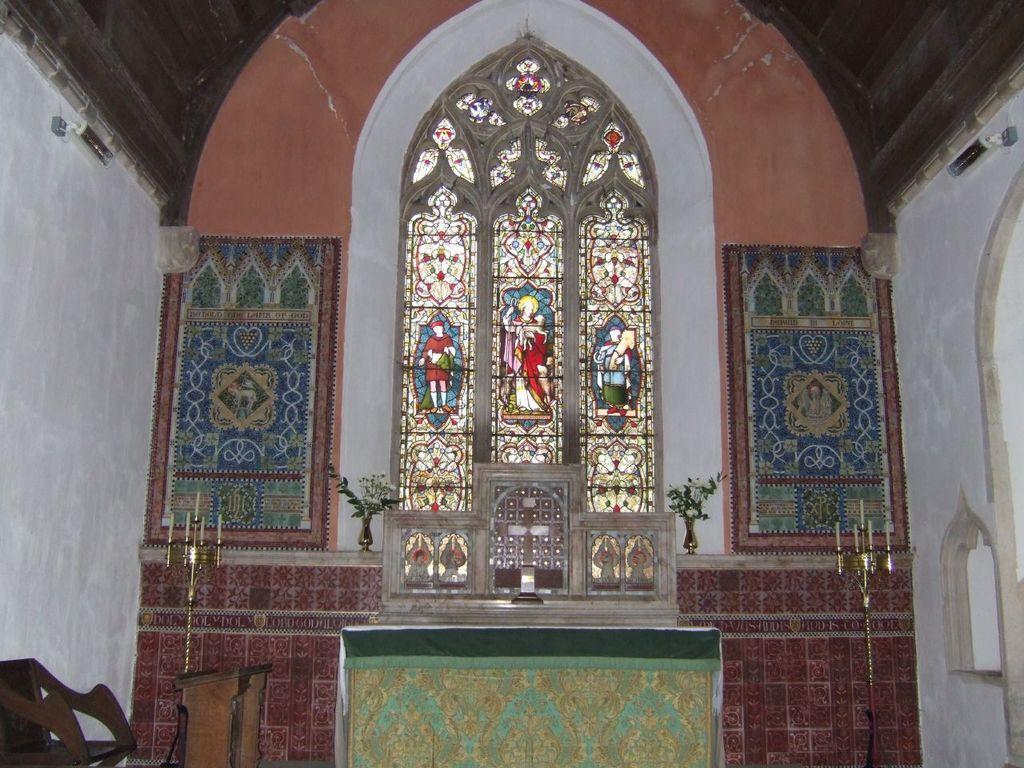How would you summarize this image in a sentence or two? In the image we can see a bench, chair, candles, wall, plant pot and a window. On the window there are pictures of people. 